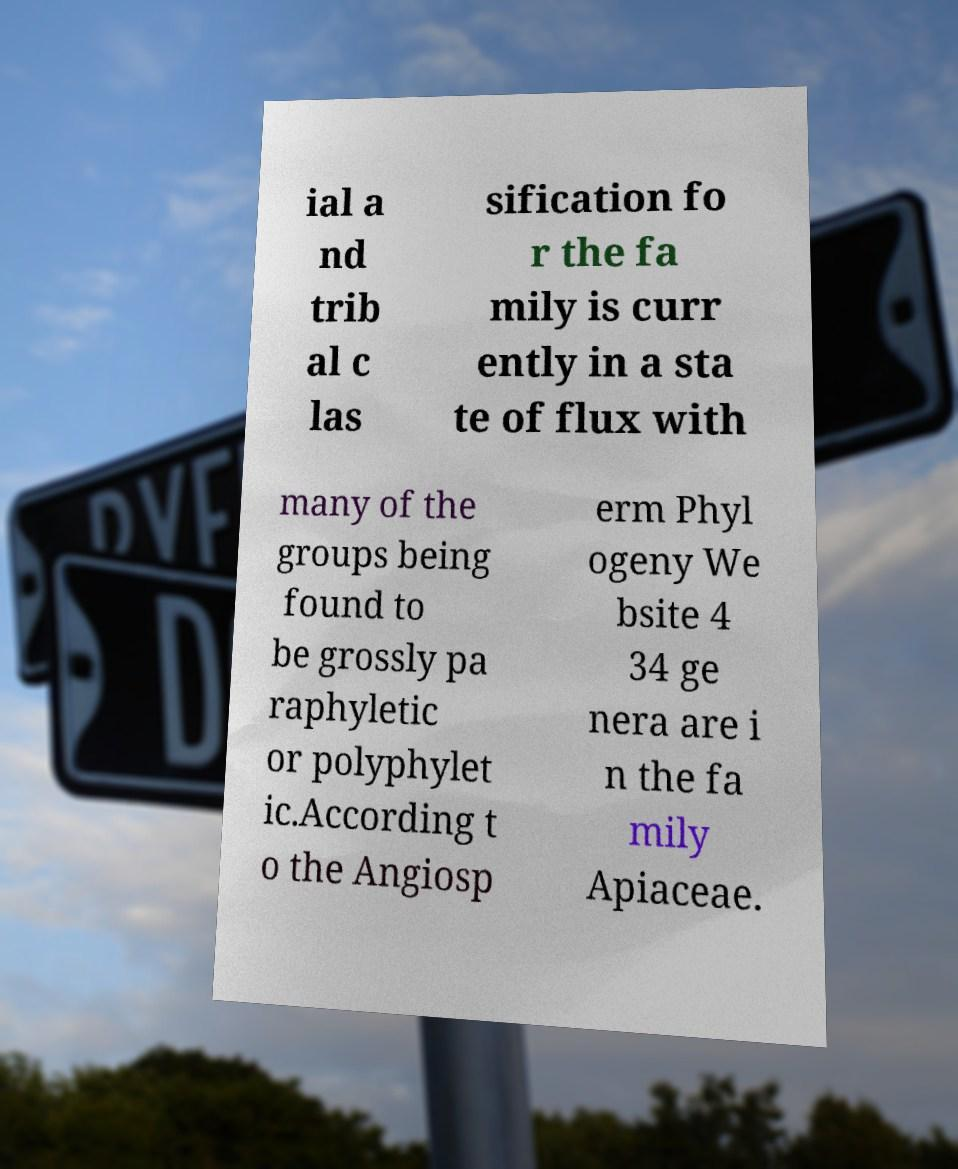Could you extract and type out the text from this image? ial a nd trib al c las sification fo r the fa mily is curr ently in a sta te of flux with many of the groups being found to be grossly pa raphyletic or polyphylet ic.According t o the Angiosp erm Phyl ogeny We bsite 4 34 ge nera are i n the fa mily Apiaceae. 